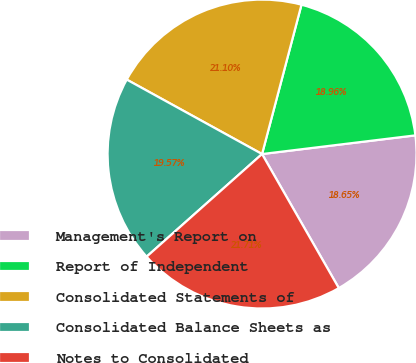Convert chart to OTSL. <chart><loc_0><loc_0><loc_500><loc_500><pie_chart><fcel>Management's Report on<fcel>Report of Independent<fcel>Consolidated Statements of<fcel>Consolidated Balance Sheets as<fcel>Notes to Consolidated<nl><fcel>18.65%<fcel>18.96%<fcel>21.1%<fcel>19.57%<fcel>21.71%<nl></chart> 